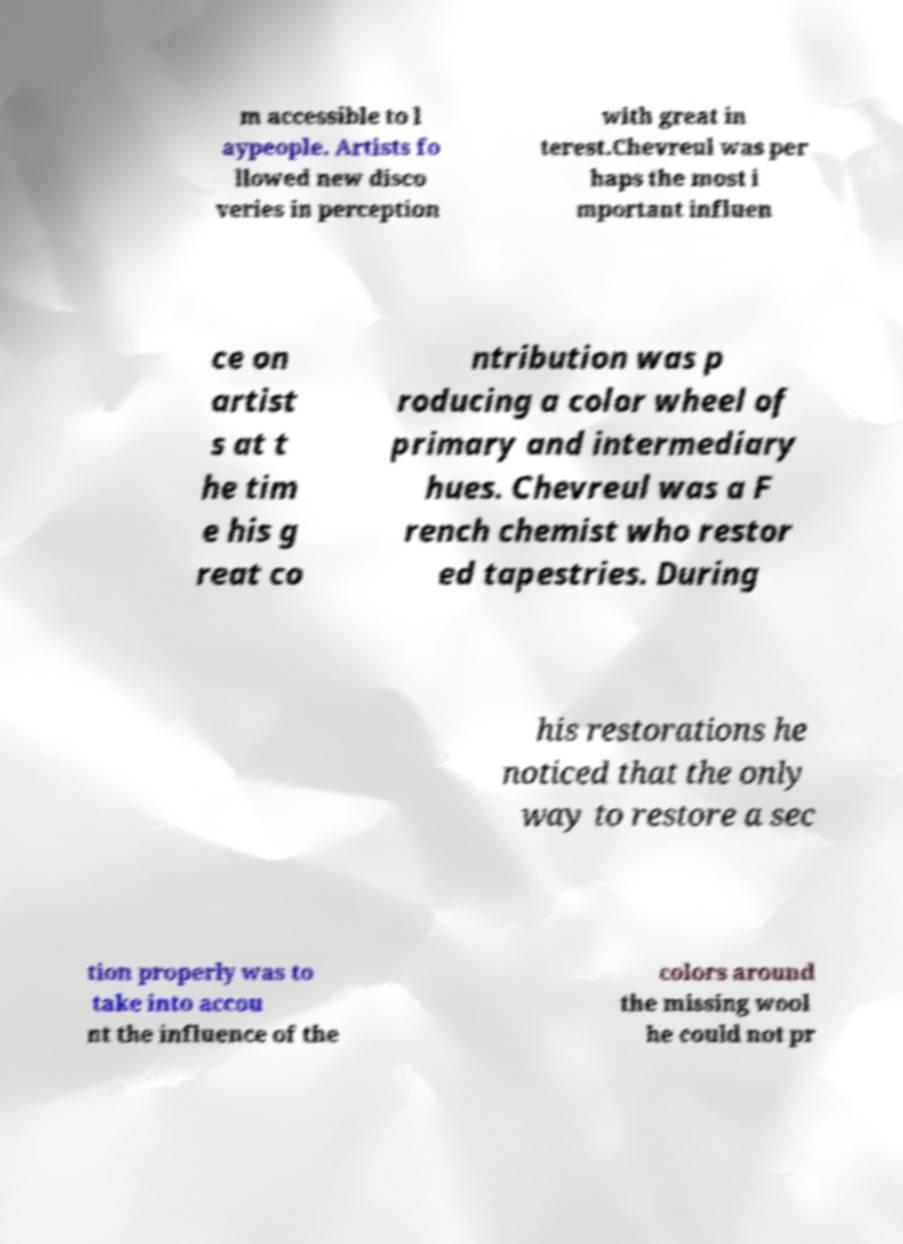Please read and relay the text visible in this image. What does it say? m accessible to l aypeople. Artists fo llowed new disco veries in perception with great in terest.Chevreul was per haps the most i mportant influen ce on artist s at t he tim e his g reat co ntribution was p roducing a color wheel of primary and intermediary hues. Chevreul was a F rench chemist who restor ed tapestries. During his restorations he noticed that the only way to restore a sec tion properly was to take into accou nt the influence of the colors around the missing wool he could not pr 